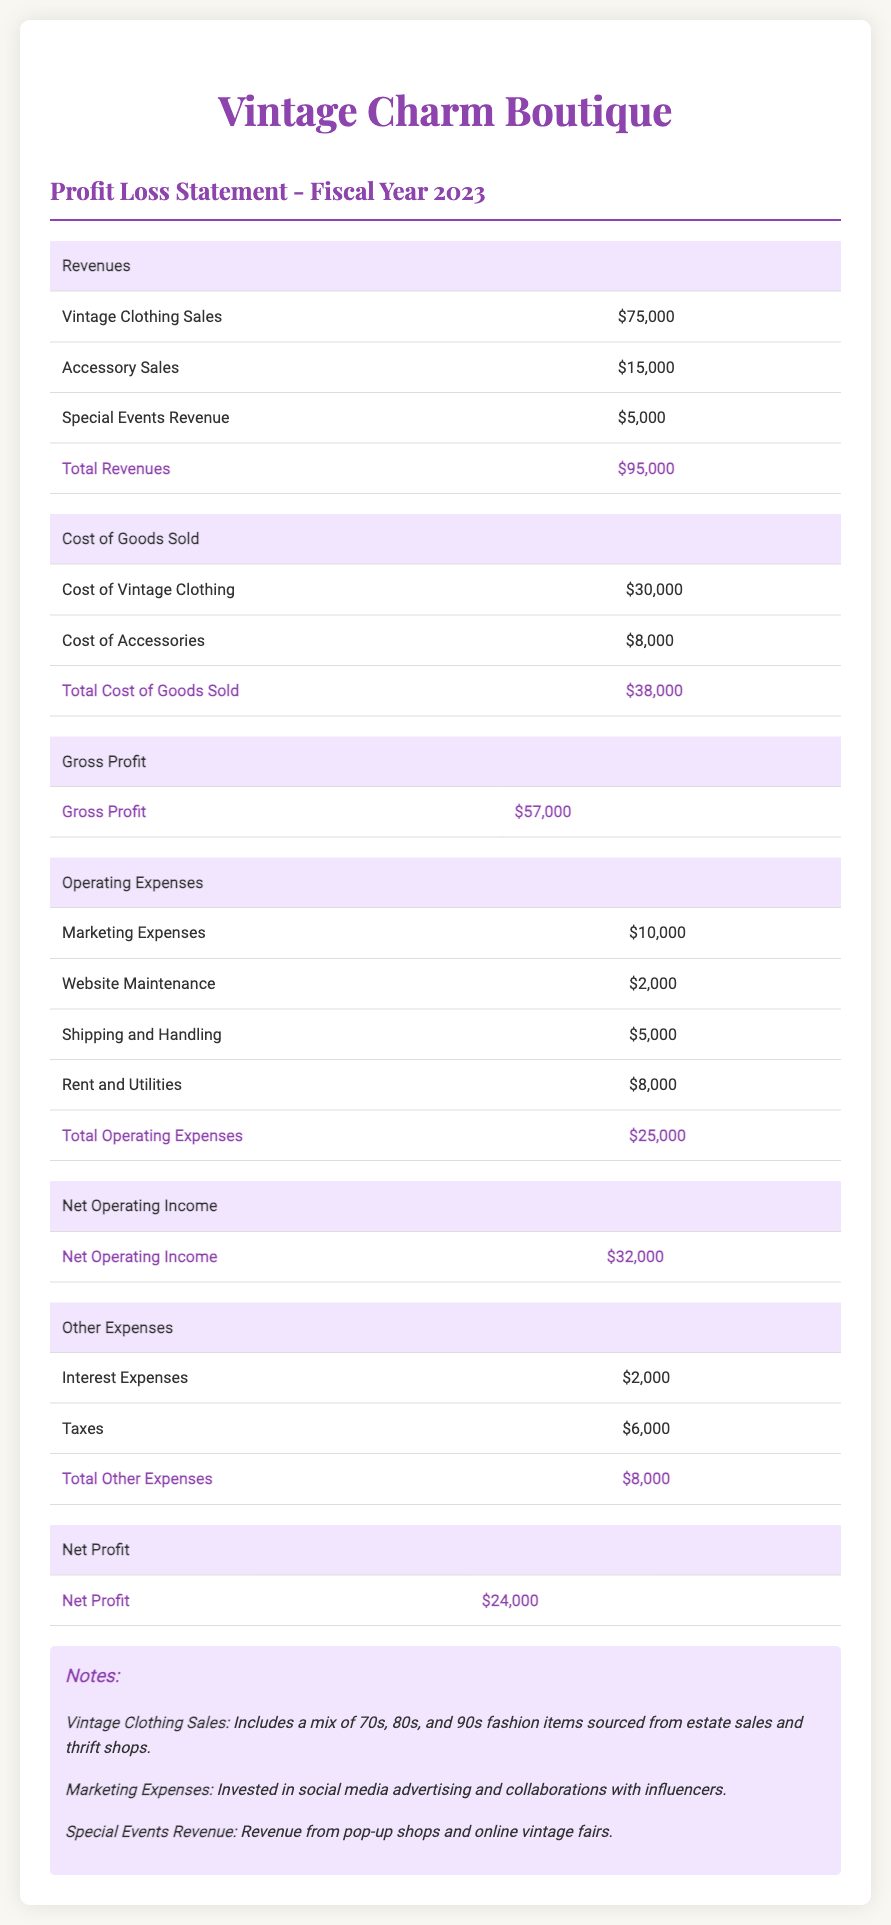What is the total revenue? The total revenue is calculated by summing all revenue sources listed: Vintage Clothing Sales, Accessory Sales, and Special Events Revenue, resulting in $75,000 + $15,000 + $5,000 = $95,000.
Answer: $95,000 What are the total operating expenses? The total operating expenses is the sum of all expenses listed under operating expenses in the document, which are Marketing Expenses, Website Maintenance, Shipping and Handling, and Rent and Utilities, calculating to $10,000 + $2,000 + $5,000 + $8,000 = $25,000.
Answer: $25,000 What is the net profit? The net profit is indicated as the final profit figure after deducting all expenses from revenues, which is provided in the document as $24,000.
Answer: $24,000 How much was spent on marketing? The document details marketing expenses specifically listed under operating expenses as $10,000.
Answer: $10,000 What is the gross profit? Gross profit is presented in the document and is calculated by subtracting the Total Cost of Goods Sold from Total Revenues, resulting in $95,000 - $38,000 = $57,000.
Answer: $57,000 What is the cost of vintage clothing? The document states that the cost of vintage clothing is $30,000.
Answer: $30,000 What were the interest expenses? The interest expenses, one of the other expenses detailed in the document, are listed as $2,000.
Answer: $2,000 How much revenue came from special events? Revenue from special events is explicitly mentioned in the document as $5,000.
Answer: $5,000 What is included in vintage clothing sales? The notes section explains that vintage clothing sales include a mix of 70s, 80s, and 90s fashion items sourced from estate sales and thrift shops.
Answer: 70s, 80s, and 90s fashion items sourced from estate sales and thrift shops 